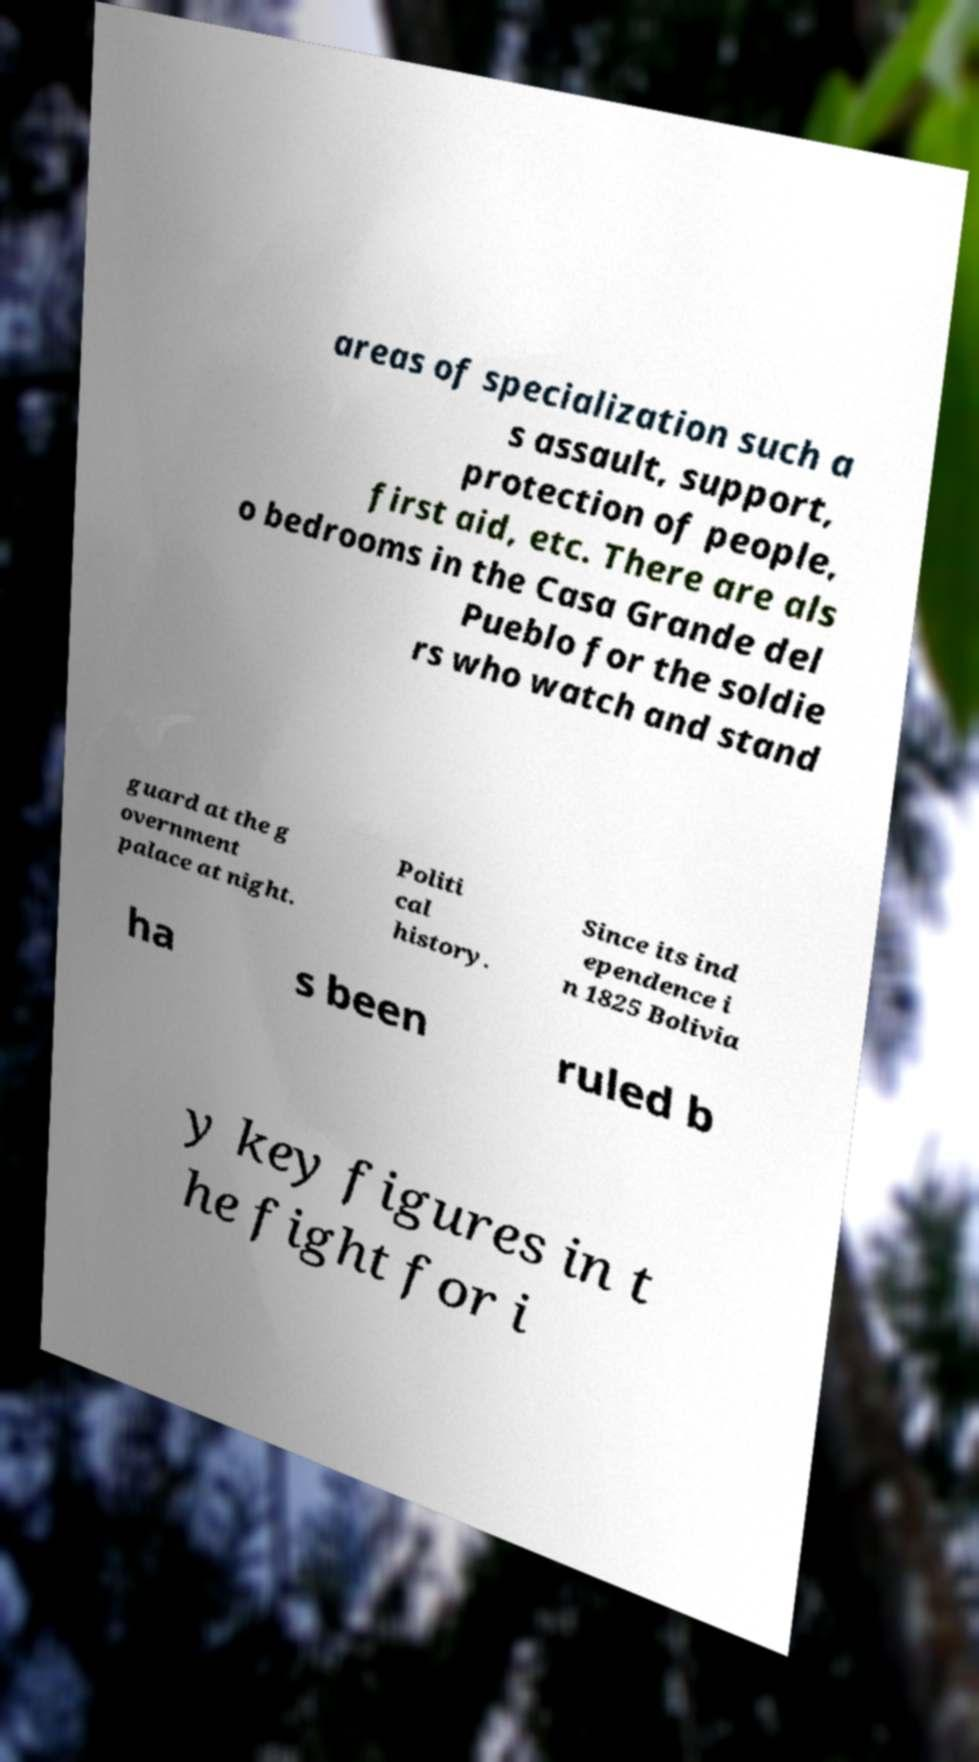Could you assist in decoding the text presented in this image and type it out clearly? areas of specialization such a s assault, support, protection of people, first aid, etc. There are als o bedrooms in the Casa Grande del Pueblo for the soldie rs who watch and stand guard at the g overnment palace at night. Politi cal history. Since its ind ependence i n 1825 Bolivia ha s been ruled b y key figures in t he fight for i 